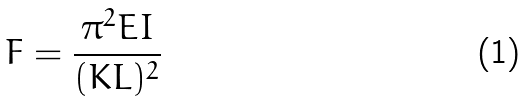<formula> <loc_0><loc_0><loc_500><loc_500>F = \frac { \pi ^ { 2 } E I } { ( K L ) ^ { 2 } }</formula> 